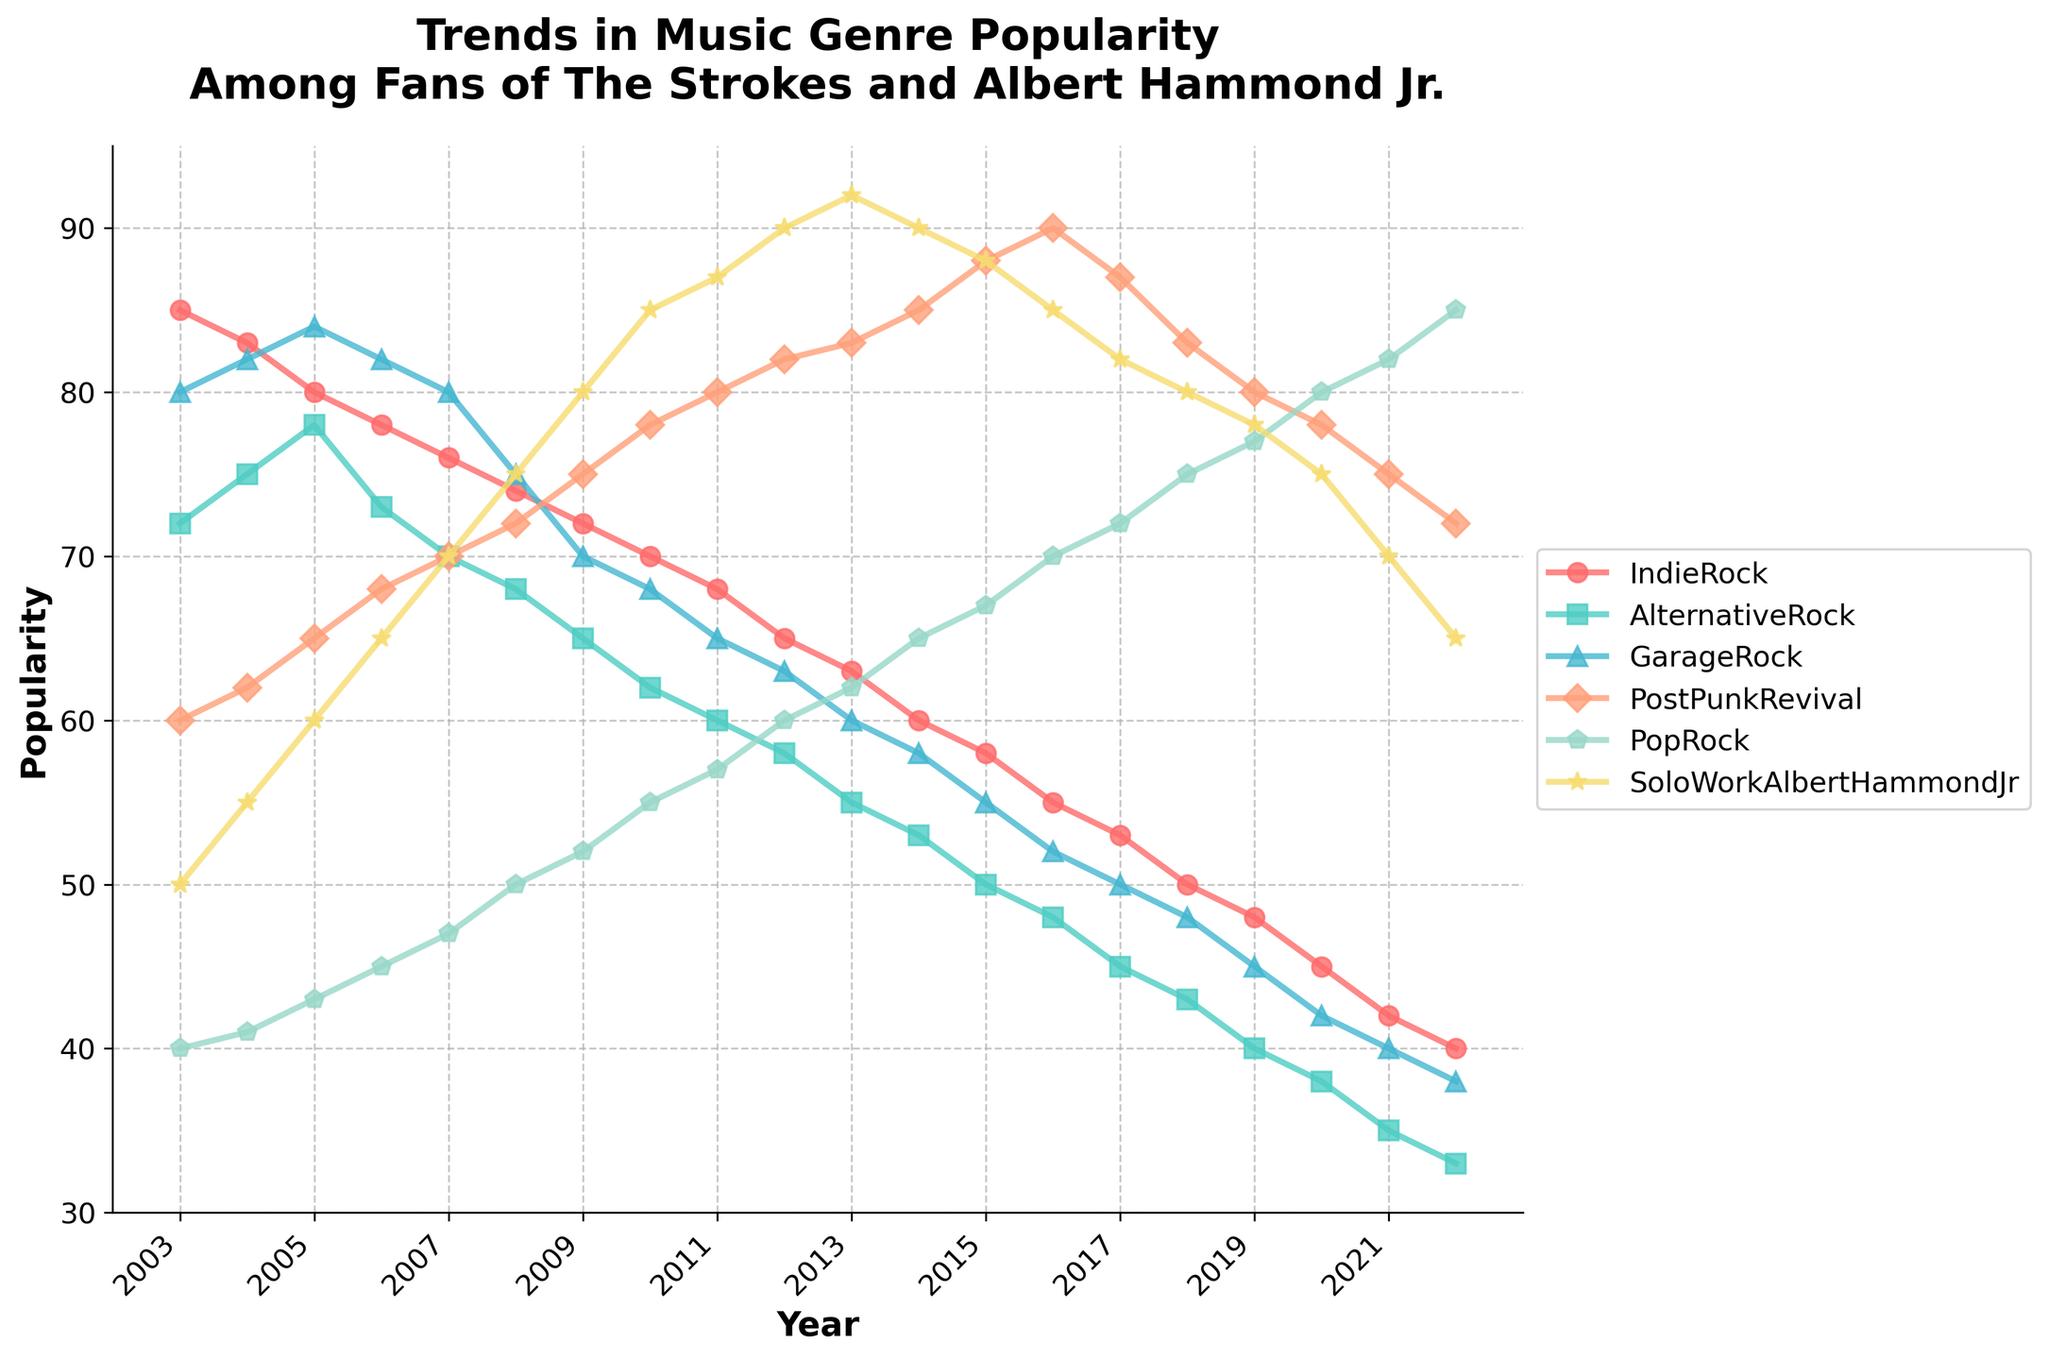what's the title of the figure? The title is displayed prominently at the top of the figure in a larger font size and bold style. It reads "Trends in Music Genre Popularity Among Fans of The Strokes and Albert Hammond Jr."
Answer: Trends in Music Genre Popularity Among Fans of The Strokes and Albert Hammond Jr How did the popularity of "Indie Rock" change from 2003 to 2022? Observing the line for "Indie Rock," its popularity started at 85 in 2003 and steadily declined to 40 in 2022.
Answer: Declined from 85 to 40 In which year did "Solo Work of Albert Hammond Jr." reach its peak in popularity? The highest point visible on the line for "Solo Work of Albert Hammond Jr." occurs in 2013 when it hits 92.
Answer: 2013 Compare the trends of "Post Punk Revival" and "Pop Rock." Which genre showed a more significant increase from 2003 to 2022? "Post Punk Revival" started at 60 in 2003 and increased to 72 in 2022. "Pop Rock" started at 40 in 2003 and increased to 85 in 2022. Therefore, "Pop Rock" showed a more significant increase.
Answer: Pop Rock What is the difference in popularity between "Garage Rock" and "Alternative Rock" in 2015? In 2015, "Garage Rock" was at 55, and "Alternative Rock" was at 50. The difference in popularity is 55 - 50 = 5.
Answer: 5 Among the genres "Indie Rock," "Alternative Rock," and "Garage Rock," which had the least decline in popularity between 2003 and 2022? By calculating the differences: "Indie Rock" declined by (85-40) = 45, "Alternative Rock" by (72-33) = 39, and "Garage Rock" by (80-38) = 42. The least decline is 39 for "Alternative Rock."
Answer: Alternative Rock What is the average popularity of "Post Punk Revival" from 2010 to 2020? Sum the popularity values from 2010 (78), 2011 (80), 2012 (82), 2013 (83), 2014 (85), 2015 (88), 2016 (90), 2017 (87), 2018 (83), 2019 (80), and 2020 (78) and divide by the number of years (11). The sum is 914, so the average is 914/11 = 83.09 (approximately).
Answer: 83.09 Which genre showed a steady increase in popularity from 2010 to 2015? Observing the slope of the lines between 2010 and 2015, "Post Punk Revival" shows a steady increase, rising from 78 to 88.
Answer: Post Punk Revival Are there any genres where popularity in 2022 was lower than in 2003? If so, which ones? Comparing the values for 2003 and 2022 for each genre: "Indie Rock" (85 to 40), "Alternative Rock" (72 to 33), "Garage Rock" (80 to 38) have declined in popularity. These genres fit the criteria.
Answer: Indie Rock, Alternative Rock, Garage Rock 